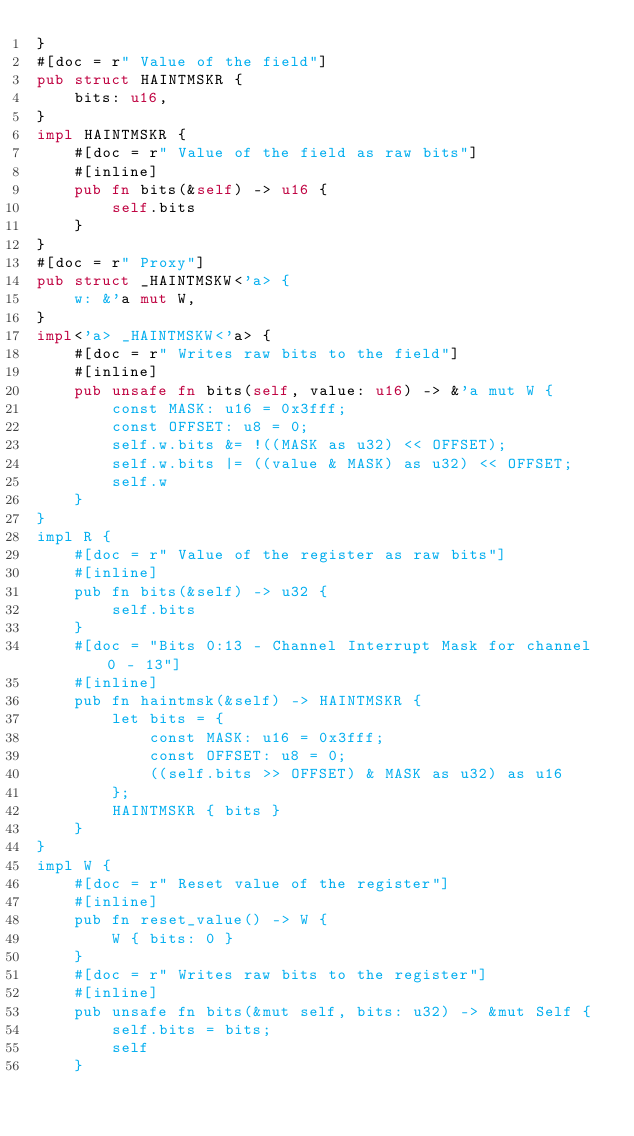<code> <loc_0><loc_0><loc_500><loc_500><_Rust_>}
#[doc = r" Value of the field"]
pub struct HAINTMSKR {
    bits: u16,
}
impl HAINTMSKR {
    #[doc = r" Value of the field as raw bits"]
    #[inline]
    pub fn bits(&self) -> u16 {
        self.bits
    }
}
#[doc = r" Proxy"]
pub struct _HAINTMSKW<'a> {
    w: &'a mut W,
}
impl<'a> _HAINTMSKW<'a> {
    #[doc = r" Writes raw bits to the field"]
    #[inline]
    pub unsafe fn bits(self, value: u16) -> &'a mut W {
        const MASK: u16 = 0x3fff;
        const OFFSET: u8 = 0;
        self.w.bits &= !((MASK as u32) << OFFSET);
        self.w.bits |= ((value & MASK) as u32) << OFFSET;
        self.w
    }
}
impl R {
    #[doc = r" Value of the register as raw bits"]
    #[inline]
    pub fn bits(&self) -> u32 {
        self.bits
    }
    #[doc = "Bits 0:13 - Channel Interrupt Mask for channel 0 - 13"]
    #[inline]
    pub fn haintmsk(&self) -> HAINTMSKR {
        let bits = {
            const MASK: u16 = 0x3fff;
            const OFFSET: u8 = 0;
            ((self.bits >> OFFSET) & MASK as u32) as u16
        };
        HAINTMSKR { bits }
    }
}
impl W {
    #[doc = r" Reset value of the register"]
    #[inline]
    pub fn reset_value() -> W {
        W { bits: 0 }
    }
    #[doc = r" Writes raw bits to the register"]
    #[inline]
    pub unsafe fn bits(&mut self, bits: u32) -> &mut Self {
        self.bits = bits;
        self
    }</code> 